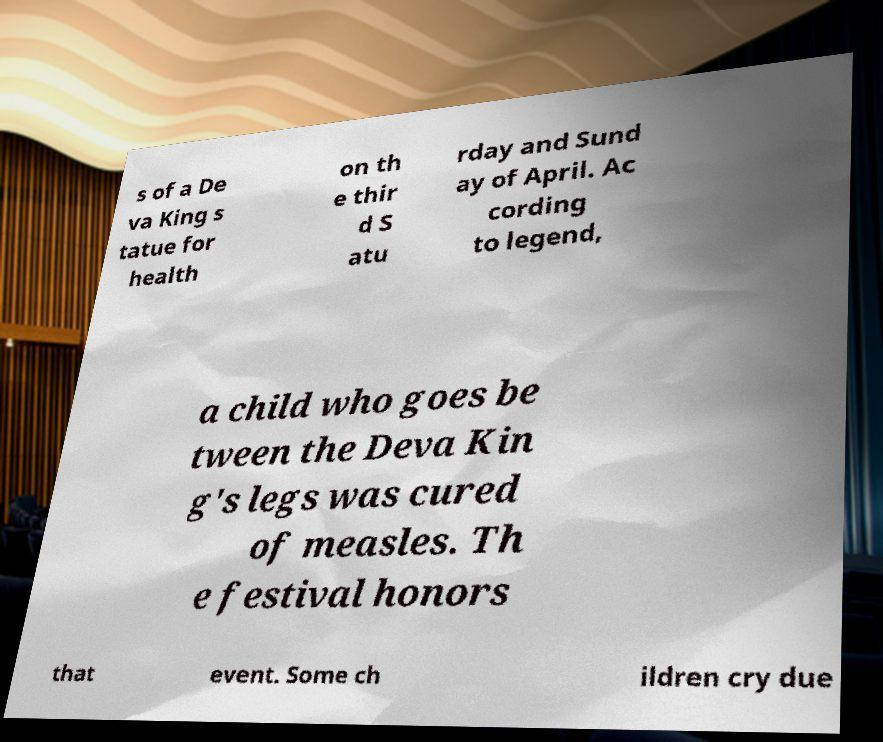Can you accurately transcribe the text from the provided image for me? s of a De va King s tatue for health on th e thir d S atu rday and Sund ay of April. Ac cording to legend, a child who goes be tween the Deva Kin g's legs was cured of measles. Th e festival honors that event. Some ch ildren cry due 